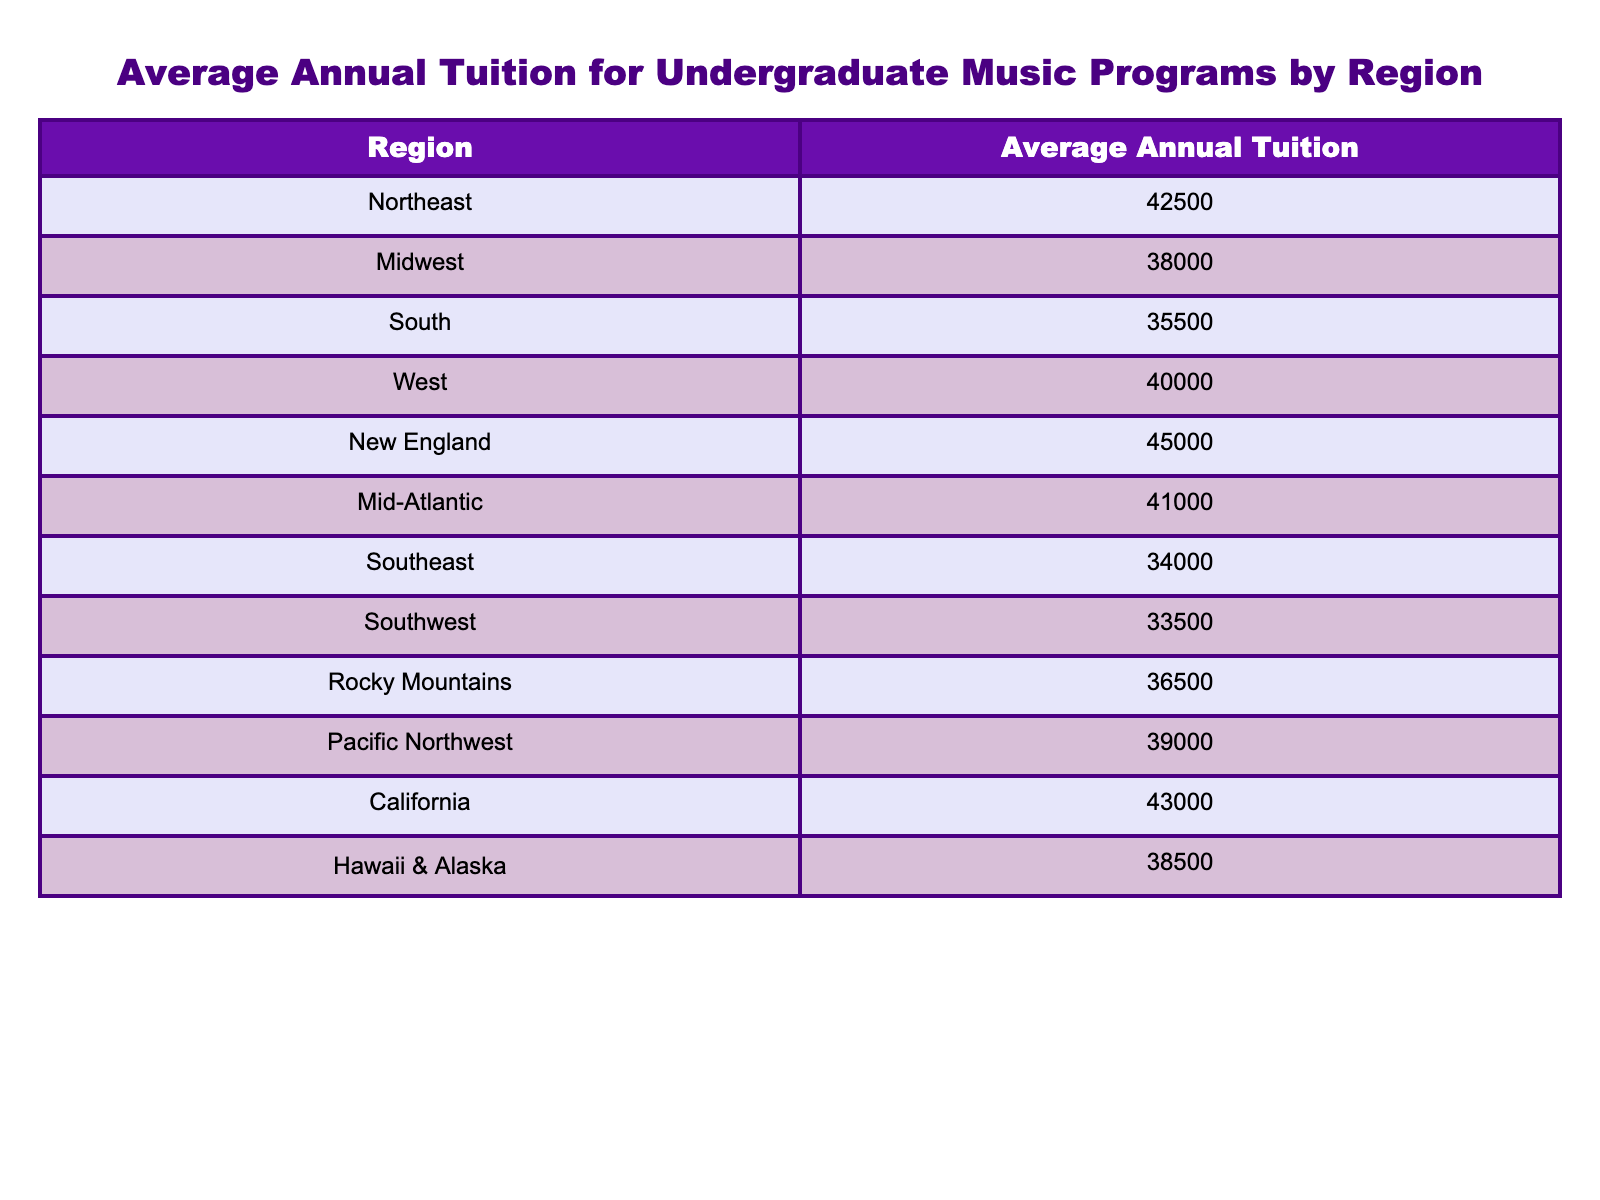What is the average tuition cost in the South region? The table states that the average annual tuition for the South region is $35,500.
Answer: $35,500 Which region has the highest average tuition cost? The table indicates that New England has the highest average annual tuition cost at $45,000.
Answer: New England What is the difference in average tuition costs between the Northeast and the Midwest? The Northeast tuition is $42,500 and the Midwest tuition is $38,000. The difference is $42,500 - $38,000 = $4,500.
Answer: $4,500 Is the average tuition cost in the Rocky Mountains greater than $36,000? The average tuition cost in the Rocky Mountains is $36,500, which is indeed greater than $36,000, confirming the statement is true.
Answer: True What is the average tuition cost of the Pacific Northwest and Southwest regions combined? The Pacific Northwest's tuition is $39,000, and the Southwest's is $33,500. The combined total is $39,000 + $33,500 = $72,500, and dividing by 2 gives an average of $72,500 / 2 = $36,250.
Answer: $36,250 Which region has the lowest average annual tuition for music programs? According to the table, the Southeast region has the lowest average annual tuition at $34,000.
Answer: Southeast If we list the regions in order from highest to lowest average tuition, what will be the top three regions? The table lists the average tuition amounts, allowing the ranking: New England ($45,000), California ($43,000), and Northeast ($42,500), so the top three are New England, California, and Northeast.
Answer: New England, California, Northeast What is the average annual tuition for the Mid-Atlantic compared to the average for the South? The Mid-Atlantic tuition is $41,000, and the South tuition is $35,500. The Mid-Atlantic is higher by $41,000 - $35,500 = $5,500.
Answer: $5,500 Are the average tuition costs in California and Hawaii & Alaska both over $38,000? California's average is $43,000 and Hawaii & Alaska's is $38,500; both are over $38,000, making the statement true.
Answer: True What is the total average tuition cost for all listed regions? Adding all the average tuition amounts from the table gives: $42,500 + $38,000 + $35,500 + $40,000 + $45,000 + $41,000 + $34,000 + $33,500 + $36,500 + $39,000 + $43,000 + $38,500 = $470,500.
Answer: $470,500 